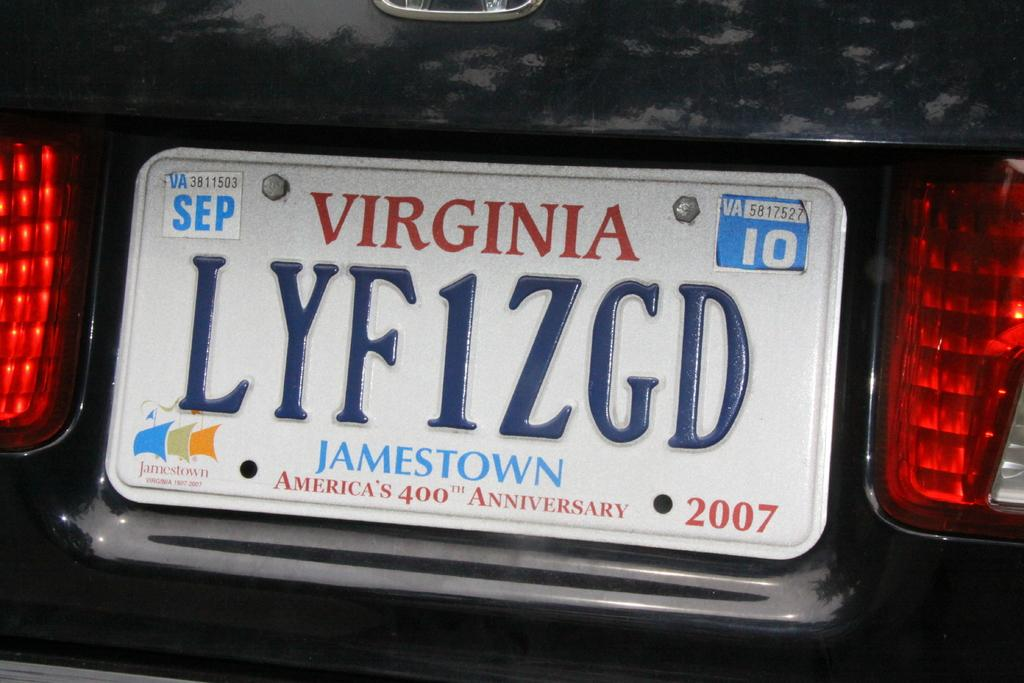Provide a one-sentence caption for the provided image. A car licence plate from the state of Virginia with a logo at the bottom that says Jamestown. 